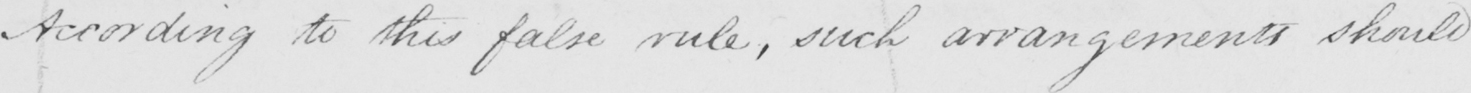Transcribe the text shown in this historical manuscript line. According to this false rule , such arrangements should 